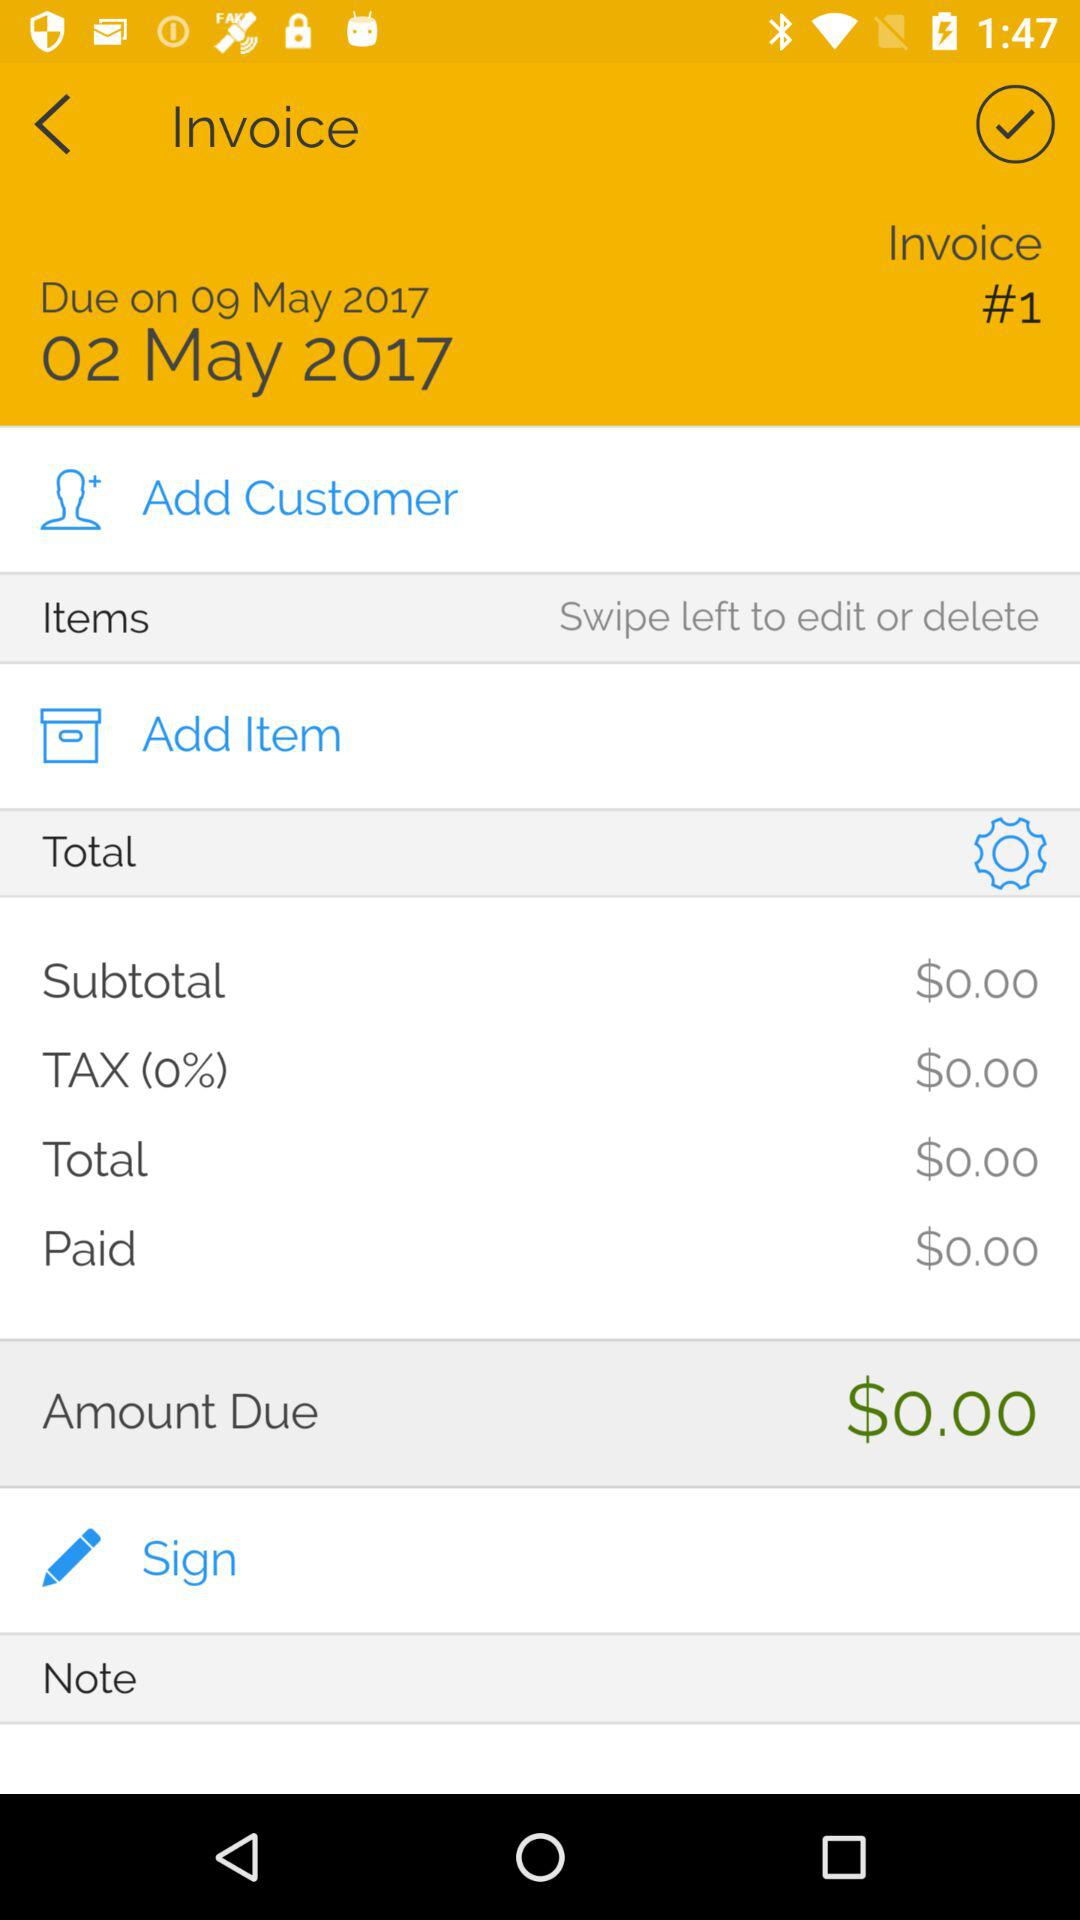What is the due date of this invoice?
Answer the question using a single word or phrase. 09 May 2017 